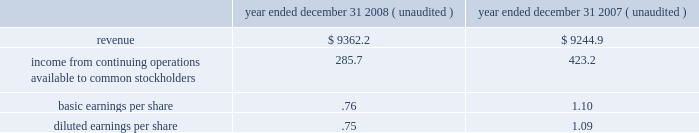Substantially all of the goodwill and other intangible assets recorded related to the acquisition of allied are not deductible for tax purposes .
Pro forma information the consolidated financial statements presented for republic include the operating results of allied from the date of the acquisition .
The following pro forma information is presented assuming the merger had been completed as of january 1 , 2007 .
The unaudited pro forma information presented below has been prepared for illustrative purposes and is not intended to be indicative of the results of operations that would have actually occurred had the acquisition been consummated at the beginning of the periods presented or of future results of the combined operations ( in millions , except share and per share amounts ) .
Year ended december 31 , year ended december 31 , ( unaudited ) ( unaudited ) .
The above unaudited pro forma financial information includes adjustments for amortization of identifiable intangible assets , accretion of discounts to fair value associated with debt , environmental , self-insurance and other liabilities , accretion of capping , closure and post-closure obligations and amortization of the related assets , and provision for income taxes .
Assets held for sale as a condition of the merger with allied in december 2008 , we reached a settlement with the doj requiring us to divest of certain operations serving fifteen metropolitan areas including los angeles , ca ; san francisco , ca ; denver , co ; atlanta , ga ; northwestern indiana ; lexington , ky ; flint , mi ; cape girardeau , mo ; charlotte , nc ; cleveland , oh ; philadelphia , pa ; greenville-spartanburg , sc ; and fort worth , houston and lubbock , tx .
The settlement requires us to divest 87 commercial waste collection routes , nine landfills and ten transfer stations , together with ancillary assets and , in three cases , access to landfill disposal capacity .
We have classified the assets and liabilities we expect to divest ( including accounts receivable , property and equipment , goodwill , and accrued landfill and environmental costs ) as assets held for sale in our consolidated balance sheet at december 31 , 2008 .
The assets held for sale related to operations that were republic 2019s prior to the merger with allied have been adjusted to the lower of their carrying amounts or estimated fair values less costs to sell , which resulted in us recognizing an asset impairment loss of $ 6.1 million in our consolidated statement of income for the year ended december 31 , 2008 .
The assets held for sale related to operations that were allied 2019s prior to the merger are recorded at their estimated fair values in our consolidated balance sheet as of december 31 , 2008 in accordance with the purchase method of accounting .
In february 2009 , we entered into an agreement to divest certain assets to waste connections , inc .
The assets covered by the agreement include six municipal solid waste landfills , six collection operations and three transfer stations across the following seven markets : los angeles , ca ; denver , co ; houston , tx ; lubbock , tx ; greenville-spartanburg , sc ; charlotte , nc ; and flint , mi .
The transaction with waste connections is subject to closing conditions regarding due diligence , regulatory approval and other customary matters .
Closing is expected to occur in the second quarter of 2009 .
Republic services , inc .
And subsidiaries notes to consolidated financial statements %%transmsg*** transmitting job : p14076 pcn : 106000000 ***%%pcmsg|104 |00046|yes|no|02/28/2009 21:07|0|0|page is valid , no graphics -- color : d| .
What was the percent of the growth in the revenues from 2007 to 2008? 
Rationale: the percent growth of the revenue is the difference between the 2 divide by the oldest amount
Computations: ((9362.2 - 9244.9) / 9244.9)
Answer: 0.01269. 